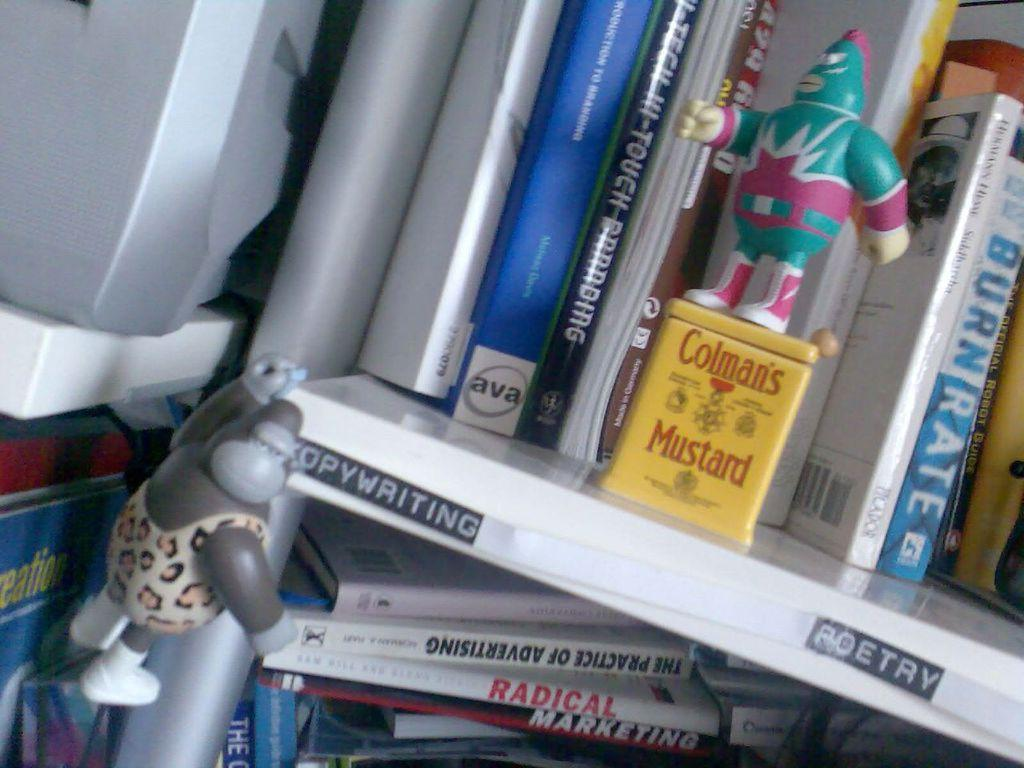<image>
Give a short and clear explanation of the subsequent image. A green action figure stands on top of a container that says "Colman's Mustard." 